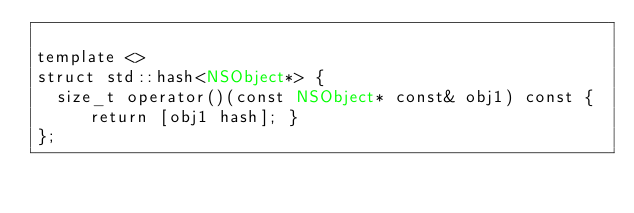<code> <loc_0><loc_0><loc_500><loc_500><_ObjectiveC_>
template <>
struct std::hash<NSObject*> {
  size_t operator()(const NSObject* const& obj1) const { return [obj1 hash]; }
};
</code> 